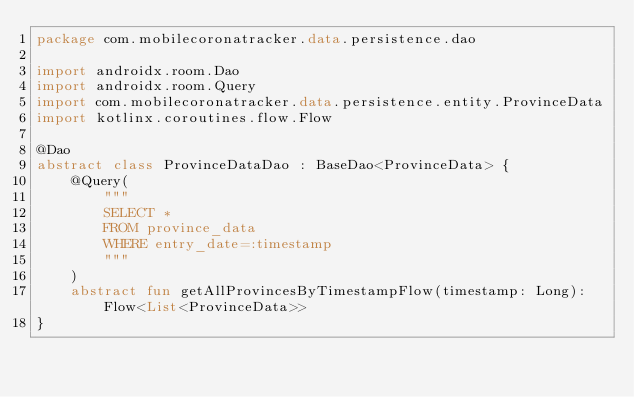Convert code to text. <code><loc_0><loc_0><loc_500><loc_500><_Kotlin_>package com.mobilecoronatracker.data.persistence.dao

import androidx.room.Dao
import androidx.room.Query
import com.mobilecoronatracker.data.persistence.entity.ProvinceData
import kotlinx.coroutines.flow.Flow

@Dao
abstract class ProvinceDataDao : BaseDao<ProvinceData> {
    @Query(
        """
        SELECT * 
        FROM province_data 
        WHERE entry_date=:timestamp
        """
    )
    abstract fun getAllProvincesByTimestampFlow(timestamp: Long): Flow<List<ProvinceData>>
}
</code> 